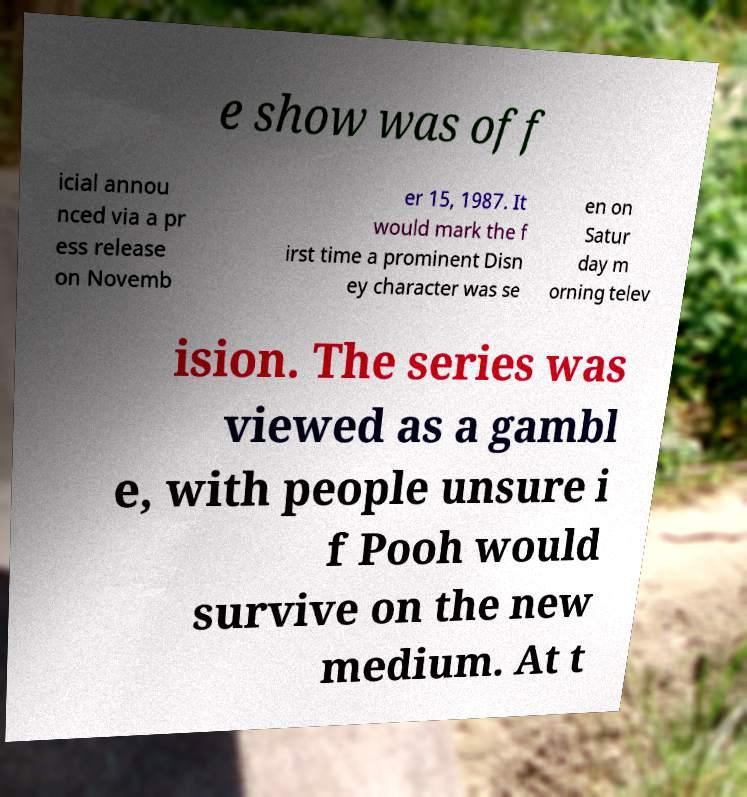Can you accurately transcribe the text from the provided image for me? e show was off icial annou nced via a pr ess release on Novemb er 15, 1987. It would mark the f irst time a prominent Disn ey character was se en on Satur day m orning telev ision. The series was viewed as a gambl e, with people unsure i f Pooh would survive on the new medium. At t 